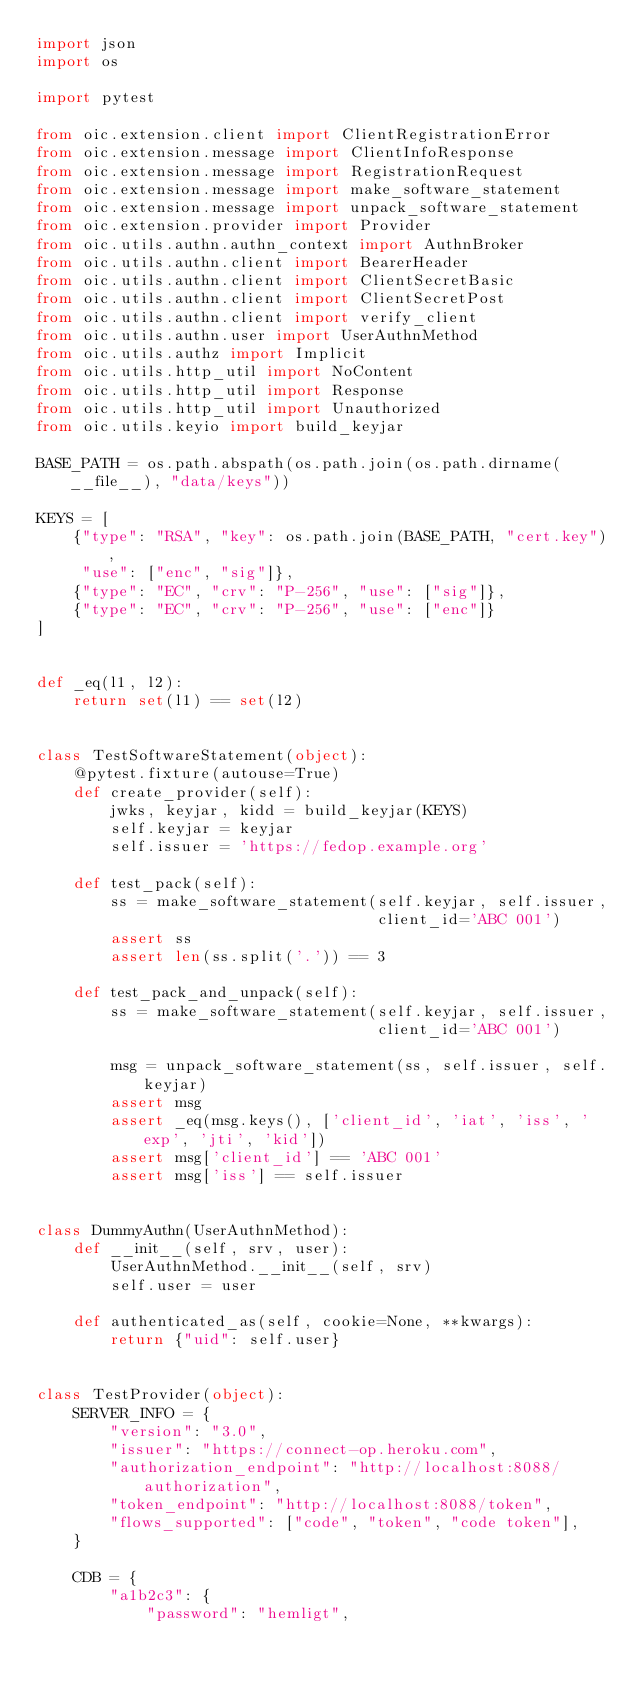Convert code to text. <code><loc_0><loc_0><loc_500><loc_500><_Python_>import json
import os

import pytest

from oic.extension.client import ClientRegistrationError
from oic.extension.message import ClientInfoResponse
from oic.extension.message import RegistrationRequest
from oic.extension.message import make_software_statement
from oic.extension.message import unpack_software_statement
from oic.extension.provider import Provider
from oic.utils.authn.authn_context import AuthnBroker
from oic.utils.authn.client import BearerHeader
from oic.utils.authn.client import ClientSecretBasic
from oic.utils.authn.client import ClientSecretPost
from oic.utils.authn.client import verify_client
from oic.utils.authn.user import UserAuthnMethod
from oic.utils.authz import Implicit
from oic.utils.http_util import NoContent
from oic.utils.http_util import Response
from oic.utils.http_util import Unauthorized
from oic.utils.keyio import build_keyjar

BASE_PATH = os.path.abspath(os.path.join(os.path.dirname(__file__), "data/keys"))

KEYS = [
    {"type": "RSA", "key": os.path.join(BASE_PATH, "cert.key"),
     "use": ["enc", "sig"]},
    {"type": "EC", "crv": "P-256", "use": ["sig"]},
    {"type": "EC", "crv": "P-256", "use": ["enc"]}
]


def _eq(l1, l2):
    return set(l1) == set(l2)


class TestSoftwareStatement(object):
    @pytest.fixture(autouse=True)
    def create_provider(self):
        jwks, keyjar, kidd = build_keyjar(KEYS)
        self.keyjar = keyjar
        self.issuer = 'https://fedop.example.org'

    def test_pack(self):
        ss = make_software_statement(self.keyjar, self.issuer,
                                     client_id='ABC 001')
        assert ss
        assert len(ss.split('.')) == 3

    def test_pack_and_unpack(self):
        ss = make_software_statement(self.keyjar, self.issuer,
                                     client_id='ABC 001')

        msg = unpack_software_statement(ss, self.issuer, self.keyjar)
        assert msg
        assert _eq(msg.keys(), ['client_id', 'iat', 'iss', 'exp', 'jti', 'kid'])
        assert msg['client_id'] == 'ABC 001'
        assert msg['iss'] == self.issuer


class DummyAuthn(UserAuthnMethod):
    def __init__(self, srv, user):
        UserAuthnMethod.__init__(self, srv)
        self.user = user

    def authenticated_as(self, cookie=None, **kwargs):
        return {"uid": self.user}


class TestProvider(object):
    SERVER_INFO = {
        "version": "3.0",
        "issuer": "https://connect-op.heroku.com",
        "authorization_endpoint": "http://localhost:8088/authorization",
        "token_endpoint": "http://localhost:8088/token",
        "flows_supported": ["code", "token", "code token"],
    }

    CDB = {
        "a1b2c3": {
            "password": "hemligt",</code> 